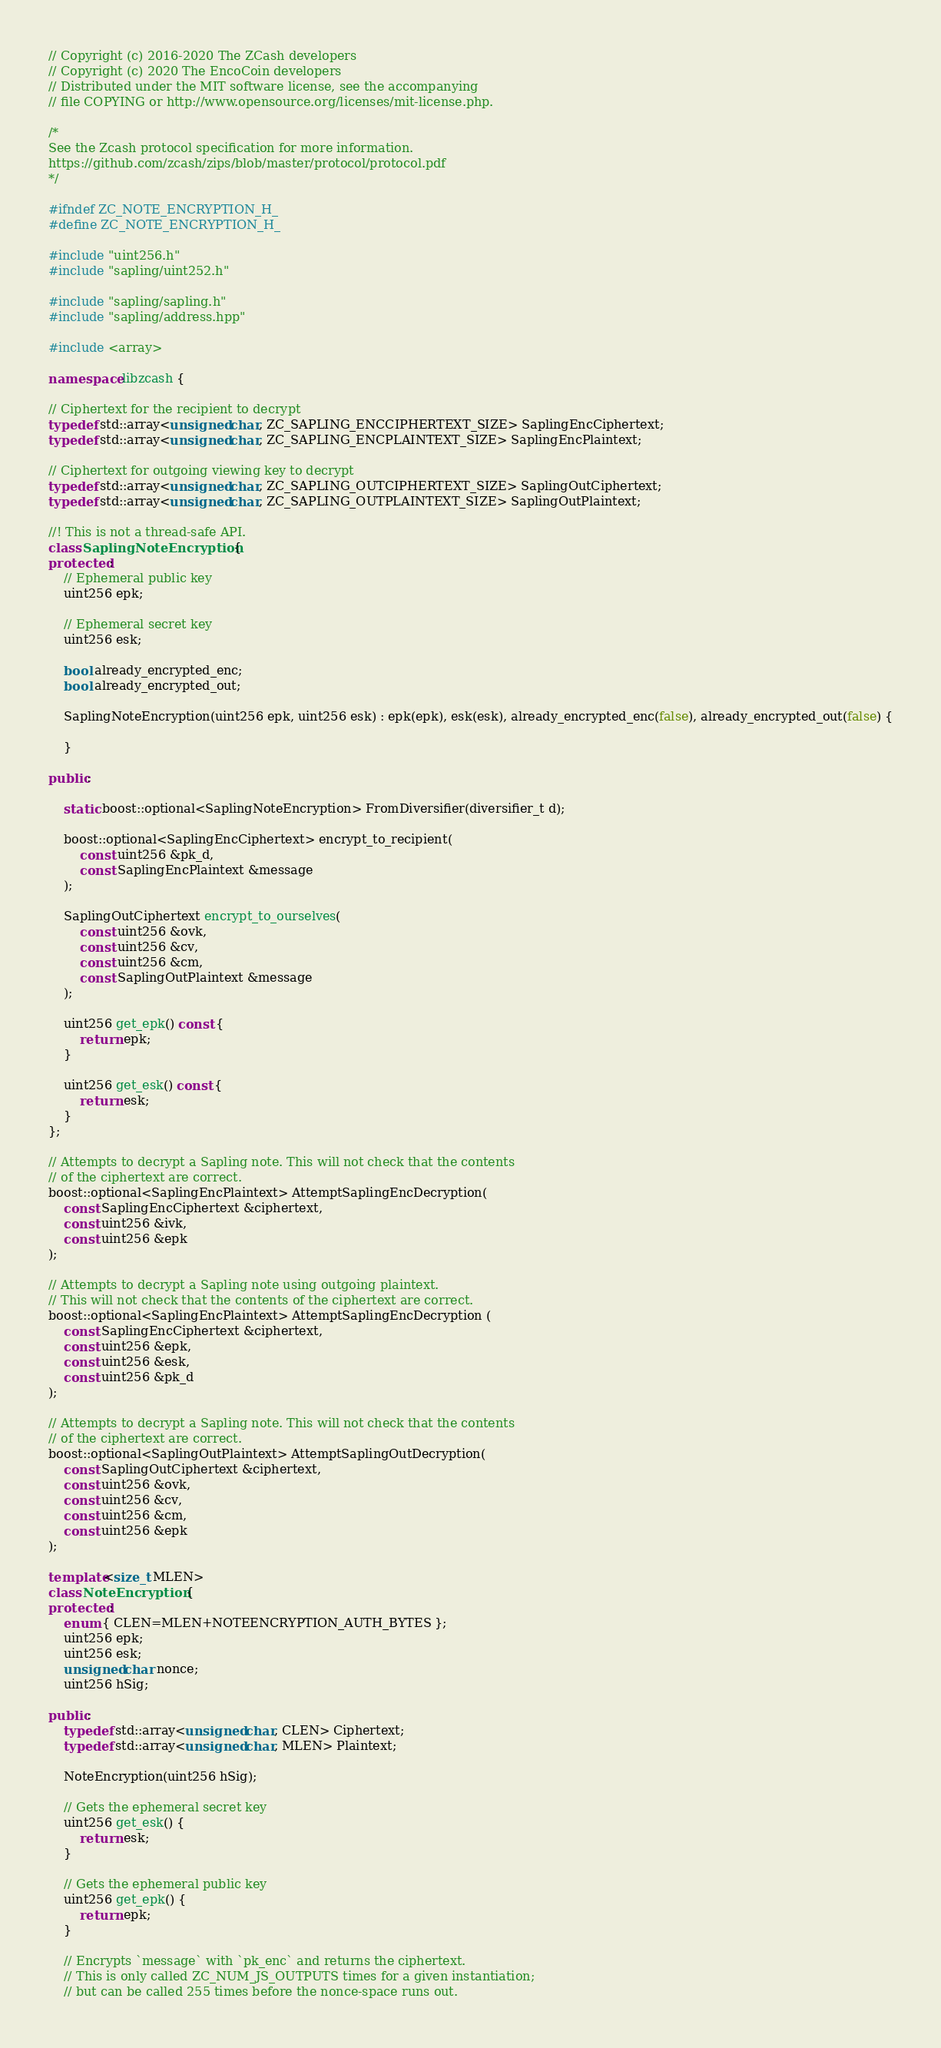<code> <loc_0><loc_0><loc_500><loc_500><_C++_>// Copyright (c) 2016-2020 The ZCash developers
// Copyright (c) 2020 The EncoCoin developers
// Distributed under the MIT software license, see the accompanying
// file COPYING or http://www.opensource.org/licenses/mit-license.php.

/*
See the Zcash protocol specification for more information.
https://github.com/zcash/zips/blob/master/protocol/protocol.pdf
*/

#ifndef ZC_NOTE_ENCRYPTION_H_
#define ZC_NOTE_ENCRYPTION_H_

#include "uint256.h"
#include "sapling/uint252.h"

#include "sapling/sapling.h"
#include "sapling/address.hpp"

#include <array>

namespace libzcash {

// Ciphertext for the recipient to decrypt
typedef std::array<unsigned char, ZC_SAPLING_ENCCIPHERTEXT_SIZE> SaplingEncCiphertext;
typedef std::array<unsigned char, ZC_SAPLING_ENCPLAINTEXT_SIZE> SaplingEncPlaintext;

// Ciphertext for outgoing viewing key to decrypt
typedef std::array<unsigned char, ZC_SAPLING_OUTCIPHERTEXT_SIZE> SaplingOutCiphertext;
typedef std::array<unsigned char, ZC_SAPLING_OUTPLAINTEXT_SIZE> SaplingOutPlaintext;

//! This is not a thread-safe API.
class SaplingNoteEncryption {
protected:
    // Ephemeral public key
    uint256 epk;

    // Ephemeral secret key
    uint256 esk;

    bool already_encrypted_enc;
    bool already_encrypted_out;

    SaplingNoteEncryption(uint256 epk, uint256 esk) : epk(epk), esk(esk), already_encrypted_enc(false), already_encrypted_out(false) {

    }

public:

    static boost::optional<SaplingNoteEncryption> FromDiversifier(diversifier_t d);

    boost::optional<SaplingEncCiphertext> encrypt_to_recipient(
        const uint256 &pk_d,
        const SaplingEncPlaintext &message
    );

    SaplingOutCiphertext encrypt_to_ourselves(
        const uint256 &ovk,
        const uint256 &cv,
        const uint256 &cm,
        const SaplingOutPlaintext &message
    );

    uint256 get_epk() const {
        return epk;
    }

    uint256 get_esk() const {
        return esk;
    }
};

// Attempts to decrypt a Sapling note. This will not check that the contents
// of the ciphertext are correct.
boost::optional<SaplingEncPlaintext> AttemptSaplingEncDecryption(
    const SaplingEncCiphertext &ciphertext,
    const uint256 &ivk,
    const uint256 &epk
);

// Attempts to decrypt a Sapling note using outgoing plaintext.
// This will not check that the contents of the ciphertext are correct.
boost::optional<SaplingEncPlaintext> AttemptSaplingEncDecryption (
    const SaplingEncCiphertext &ciphertext,
    const uint256 &epk,
    const uint256 &esk,
    const uint256 &pk_d
);

// Attempts to decrypt a Sapling note. This will not check that the contents
// of the ciphertext are correct.
boost::optional<SaplingOutPlaintext> AttemptSaplingOutDecryption(
    const SaplingOutCiphertext &ciphertext,
    const uint256 &ovk,
    const uint256 &cv,
    const uint256 &cm,
    const uint256 &epk
);

template<size_t MLEN>
class NoteEncryption {
protected:
    enum { CLEN=MLEN+NOTEENCRYPTION_AUTH_BYTES };
    uint256 epk;
    uint256 esk;
    unsigned char nonce;
    uint256 hSig;

public:
    typedef std::array<unsigned char, CLEN> Ciphertext;
    typedef std::array<unsigned char, MLEN> Plaintext;

    NoteEncryption(uint256 hSig);

    // Gets the ephemeral secret key
    uint256 get_esk() {
        return esk;
    }

    // Gets the ephemeral public key
    uint256 get_epk() {
        return epk;
    }

    // Encrypts `message` with `pk_enc` and returns the ciphertext.
    // This is only called ZC_NUM_JS_OUTPUTS times for a given instantiation;
    // but can be called 255 times before the nonce-space runs out.</code> 